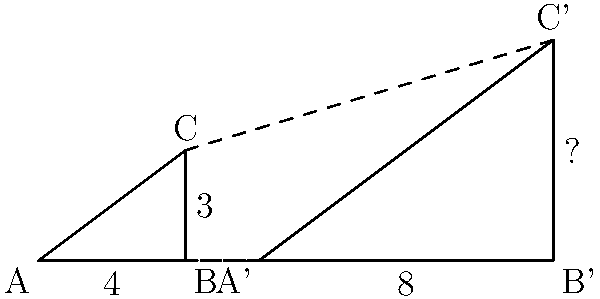Your teenage sister claims she can magically transform shapes. She shows you a right triangle ABC with base 4 units and height 3 units. She then "transforms" it into a larger similar triangle A'B'C'. The new base A'B' is 8 units long. What is the height of the new triangle B'C'? Explain your reasoning to expose the "magic" behind this transformation. Let's break down this "magical" transformation step-by-step:

1) First, we need to recognize that this is a scaling transformation. The shape remains similar (same angles), but the size has changed.

2) To find the scale factor, we compare the new base to the original base:
   $\text{Scale factor} = \frac{\text{New base}}{\text{Original base}} = \frac{8}{4} = 2$

3) In a scaling transformation, all dimensions are multiplied by the scale factor. So, if the base is doubled, the height must also be doubled.

4) The original height was 3 units. To find the new height:
   $\text{New height} = \text{Original height} \times \text{Scale factor}$
   $\text{New height} = 3 \times 2 = 6$ units

5) We can verify this using the properties of similar triangles. The ratio of corresponding sides should be constant:
   $\frac{\text{New base}}{\text{Original base}} = \frac{\text{New height}}{\text{Original height}}$
   $\frac{8}{4} = \frac{6}{3} = 2$

Therefore, the "magic" behind this transformation is simply a scaling by a factor of 2, doubling all dimensions of the original triangle.
Answer: 6 units 